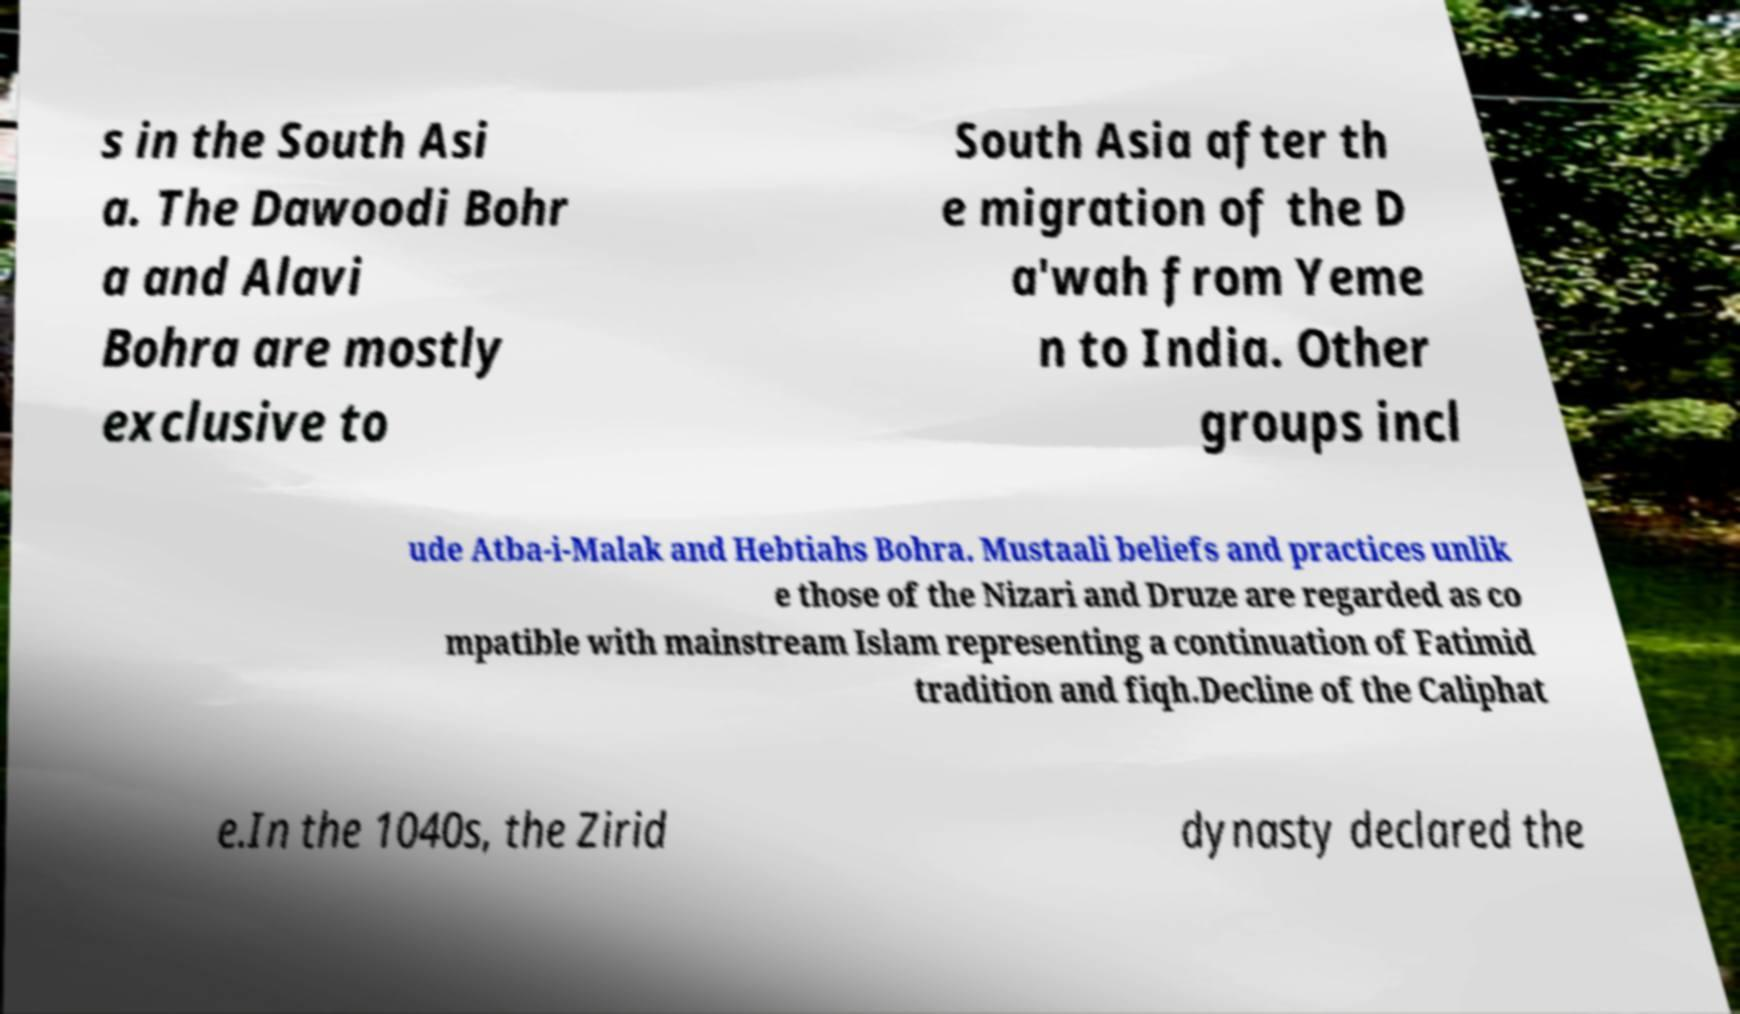There's text embedded in this image that I need extracted. Can you transcribe it verbatim? s in the South Asi a. The Dawoodi Bohr a and Alavi Bohra are mostly exclusive to South Asia after th e migration of the D a'wah from Yeme n to India. Other groups incl ude Atba-i-Malak and Hebtiahs Bohra. Mustaali beliefs and practices unlik e those of the Nizari and Druze are regarded as co mpatible with mainstream Islam representing a continuation of Fatimid tradition and fiqh.Decline of the Caliphat e.In the 1040s, the Zirid dynasty declared the 